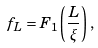Convert formula to latex. <formula><loc_0><loc_0><loc_500><loc_500>f _ { L } = F _ { 1 } \left ( \frac { L } { \xi } \right ) ,</formula> 